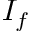<formula> <loc_0><loc_0><loc_500><loc_500>I _ { f }</formula> 